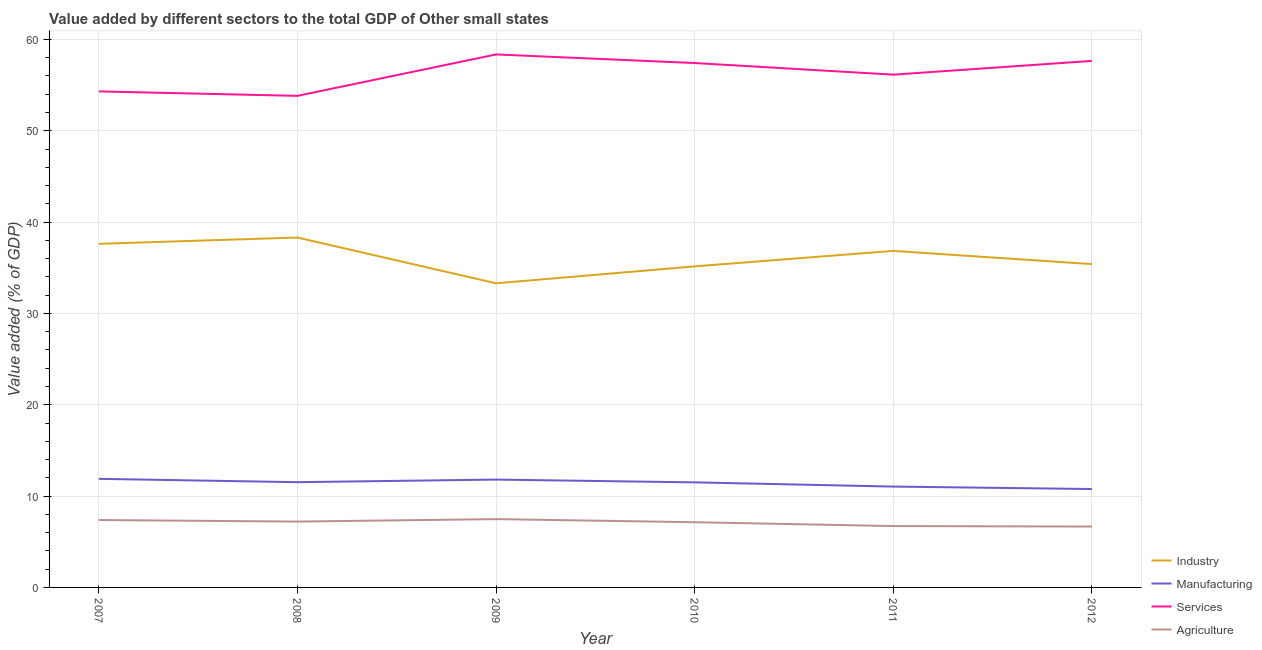Is the number of lines equal to the number of legend labels?
Your response must be concise. Yes. What is the value added by agricultural sector in 2011?
Offer a terse response. 6.72. Across all years, what is the maximum value added by industrial sector?
Your response must be concise. 38.31. Across all years, what is the minimum value added by agricultural sector?
Give a very brief answer. 6.67. In which year was the value added by services sector maximum?
Your response must be concise. 2009. What is the total value added by agricultural sector in the graph?
Make the answer very short. 42.59. What is the difference between the value added by industrial sector in 2009 and that in 2012?
Offer a terse response. -2.1. What is the difference between the value added by agricultural sector in 2009 and the value added by manufacturing sector in 2012?
Offer a terse response. -3.29. What is the average value added by industrial sector per year?
Your response must be concise. 36.1. In the year 2011, what is the difference between the value added by agricultural sector and value added by industrial sector?
Offer a terse response. -30.13. What is the ratio of the value added by agricultural sector in 2007 to that in 2008?
Provide a short and direct response. 1.02. Is the difference between the value added by agricultural sector in 2010 and 2012 greater than the difference between the value added by industrial sector in 2010 and 2012?
Make the answer very short. Yes. What is the difference between the highest and the second highest value added by agricultural sector?
Give a very brief answer. 0.1. What is the difference between the highest and the lowest value added by agricultural sector?
Your response must be concise. 0.81. Does the value added by industrial sector monotonically increase over the years?
Your response must be concise. No. Is the value added by manufacturing sector strictly greater than the value added by services sector over the years?
Offer a very short reply. No. How many years are there in the graph?
Your answer should be compact. 6. What is the difference between two consecutive major ticks on the Y-axis?
Your answer should be very brief. 10. Are the values on the major ticks of Y-axis written in scientific E-notation?
Your answer should be compact. No. Where does the legend appear in the graph?
Your answer should be compact. Bottom right. What is the title of the graph?
Your response must be concise. Value added by different sectors to the total GDP of Other small states. What is the label or title of the Y-axis?
Give a very brief answer. Value added (% of GDP). What is the Value added (% of GDP) of Industry in 2007?
Your answer should be very brief. 37.62. What is the Value added (% of GDP) of Manufacturing in 2007?
Offer a very short reply. 11.89. What is the Value added (% of GDP) in Services in 2007?
Your answer should be compact. 54.31. What is the Value added (% of GDP) of Agriculture in 2007?
Give a very brief answer. 7.38. What is the Value added (% of GDP) in Industry in 2008?
Provide a short and direct response. 38.31. What is the Value added (% of GDP) in Manufacturing in 2008?
Offer a very short reply. 11.52. What is the Value added (% of GDP) of Services in 2008?
Your answer should be compact. 53.82. What is the Value added (% of GDP) of Agriculture in 2008?
Ensure brevity in your answer.  7.21. What is the Value added (% of GDP) of Industry in 2009?
Your answer should be very brief. 33.3. What is the Value added (% of GDP) in Manufacturing in 2009?
Offer a very short reply. 11.81. What is the Value added (% of GDP) of Services in 2009?
Offer a terse response. 58.36. What is the Value added (% of GDP) in Agriculture in 2009?
Make the answer very short. 7.48. What is the Value added (% of GDP) of Industry in 2010?
Ensure brevity in your answer.  35.15. What is the Value added (% of GDP) of Manufacturing in 2010?
Ensure brevity in your answer.  11.5. What is the Value added (% of GDP) of Services in 2010?
Make the answer very short. 57.41. What is the Value added (% of GDP) in Agriculture in 2010?
Offer a very short reply. 7.14. What is the Value added (% of GDP) of Industry in 2011?
Provide a succinct answer. 36.85. What is the Value added (% of GDP) of Manufacturing in 2011?
Your response must be concise. 11.04. What is the Value added (% of GDP) in Services in 2011?
Offer a terse response. 56.14. What is the Value added (% of GDP) in Agriculture in 2011?
Offer a very short reply. 6.72. What is the Value added (% of GDP) in Industry in 2012?
Provide a succinct answer. 35.4. What is the Value added (% of GDP) of Manufacturing in 2012?
Make the answer very short. 10.77. What is the Value added (% of GDP) of Services in 2012?
Offer a very short reply. 57.65. What is the Value added (% of GDP) in Agriculture in 2012?
Provide a succinct answer. 6.67. Across all years, what is the maximum Value added (% of GDP) in Industry?
Keep it short and to the point. 38.31. Across all years, what is the maximum Value added (% of GDP) in Manufacturing?
Offer a terse response. 11.89. Across all years, what is the maximum Value added (% of GDP) in Services?
Make the answer very short. 58.36. Across all years, what is the maximum Value added (% of GDP) in Agriculture?
Provide a succinct answer. 7.48. Across all years, what is the minimum Value added (% of GDP) of Industry?
Provide a succinct answer. 33.3. Across all years, what is the minimum Value added (% of GDP) of Manufacturing?
Your answer should be very brief. 10.77. Across all years, what is the minimum Value added (% of GDP) of Services?
Make the answer very short. 53.82. Across all years, what is the minimum Value added (% of GDP) in Agriculture?
Make the answer very short. 6.67. What is the total Value added (% of GDP) in Industry in the graph?
Your answer should be very brief. 216.62. What is the total Value added (% of GDP) in Manufacturing in the graph?
Keep it short and to the point. 68.54. What is the total Value added (% of GDP) of Services in the graph?
Your answer should be very brief. 337.69. What is the total Value added (% of GDP) of Agriculture in the graph?
Give a very brief answer. 42.59. What is the difference between the Value added (% of GDP) in Industry in 2007 and that in 2008?
Ensure brevity in your answer.  -0.69. What is the difference between the Value added (% of GDP) in Manufacturing in 2007 and that in 2008?
Ensure brevity in your answer.  0.36. What is the difference between the Value added (% of GDP) in Services in 2007 and that in 2008?
Your answer should be very brief. 0.49. What is the difference between the Value added (% of GDP) of Agriculture in 2007 and that in 2008?
Give a very brief answer. 0.17. What is the difference between the Value added (% of GDP) in Industry in 2007 and that in 2009?
Ensure brevity in your answer.  4.32. What is the difference between the Value added (% of GDP) of Manufacturing in 2007 and that in 2009?
Keep it short and to the point. 0.08. What is the difference between the Value added (% of GDP) of Services in 2007 and that in 2009?
Offer a very short reply. -4.05. What is the difference between the Value added (% of GDP) in Agriculture in 2007 and that in 2009?
Provide a short and direct response. -0.1. What is the difference between the Value added (% of GDP) in Industry in 2007 and that in 2010?
Make the answer very short. 2.47. What is the difference between the Value added (% of GDP) in Manufacturing in 2007 and that in 2010?
Your response must be concise. 0.39. What is the difference between the Value added (% of GDP) of Services in 2007 and that in 2010?
Offer a terse response. -3.1. What is the difference between the Value added (% of GDP) of Agriculture in 2007 and that in 2010?
Your answer should be compact. 0.24. What is the difference between the Value added (% of GDP) of Industry in 2007 and that in 2011?
Offer a terse response. 0.77. What is the difference between the Value added (% of GDP) of Manufacturing in 2007 and that in 2011?
Your answer should be very brief. 0.85. What is the difference between the Value added (% of GDP) of Services in 2007 and that in 2011?
Your response must be concise. -1.83. What is the difference between the Value added (% of GDP) in Agriculture in 2007 and that in 2011?
Your answer should be compact. 0.66. What is the difference between the Value added (% of GDP) in Industry in 2007 and that in 2012?
Your answer should be very brief. 2.22. What is the difference between the Value added (% of GDP) of Manufacturing in 2007 and that in 2012?
Make the answer very short. 1.12. What is the difference between the Value added (% of GDP) of Services in 2007 and that in 2012?
Ensure brevity in your answer.  -3.34. What is the difference between the Value added (% of GDP) in Agriculture in 2007 and that in 2012?
Your answer should be very brief. 0.71. What is the difference between the Value added (% of GDP) of Industry in 2008 and that in 2009?
Ensure brevity in your answer.  5.01. What is the difference between the Value added (% of GDP) in Manufacturing in 2008 and that in 2009?
Offer a terse response. -0.28. What is the difference between the Value added (% of GDP) of Services in 2008 and that in 2009?
Provide a succinct answer. -4.54. What is the difference between the Value added (% of GDP) of Agriculture in 2008 and that in 2009?
Make the answer very short. -0.27. What is the difference between the Value added (% of GDP) in Industry in 2008 and that in 2010?
Provide a succinct answer. 3.16. What is the difference between the Value added (% of GDP) in Manufacturing in 2008 and that in 2010?
Keep it short and to the point. 0.02. What is the difference between the Value added (% of GDP) in Services in 2008 and that in 2010?
Your answer should be very brief. -3.59. What is the difference between the Value added (% of GDP) in Agriculture in 2008 and that in 2010?
Provide a succinct answer. 0.07. What is the difference between the Value added (% of GDP) of Industry in 2008 and that in 2011?
Ensure brevity in your answer.  1.46. What is the difference between the Value added (% of GDP) of Manufacturing in 2008 and that in 2011?
Make the answer very short. 0.48. What is the difference between the Value added (% of GDP) in Services in 2008 and that in 2011?
Ensure brevity in your answer.  -2.32. What is the difference between the Value added (% of GDP) in Agriculture in 2008 and that in 2011?
Offer a terse response. 0.49. What is the difference between the Value added (% of GDP) of Industry in 2008 and that in 2012?
Give a very brief answer. 2.91. What is the difference between the Value added (% of GDP) in Manufacturing in 2008 and that in 2012?
Keep it short and to the point. 0.75. What is the difference between the Value added (% of GDP) in Services in 2008 and that in 2012?
Make the answer very short. -3.83. What is the difference between the Value added (% of GDP) in Agriculture in 2008 and that in 2012?
Ensure brevity in your answer.  0.54. What is the difference between the Value added (% of GDP) in Industry in 2009 and that in 2010?
Provide a succinct answer. -1.85. What is the difference between the Value added (% of GDP) of Manufacturing in 2009 and that in 2010?
Offer a terse response. 0.3. What is the difference between the Value added (% of GDP) of Services in 2009 and that in 2010?
Keep it short and to the point. 0.94. What is the difference between the Value added (% of GDP) in Agriculture in 2009 and that in 2010?
Provide a succinct answer. 0.34. What is the difference between the Value added (% of GDP) in Industry in 2009 and that in 2011?
Keep it short and to the point. -3.55. What is the difference between the Value added (% of GDP) in Manufacturing in 2009 and that in 2011?
Your answer should be very brief. 0.77. What is the difference between the Value added (% of GDP) of Services in 2009 and that in 2011?
Your answer should be very brief. 2.21. What is the difference between the Value added (% of GDP) of Agriculture in 2009 and that in 2011?
Make the answer very short. 0.76. What is the difference between the Value added (% of GDP) in Industry in 2009 and that in 2012?
Provide a succinct answer. -2.1. What is the difference between the Value added (% of GDP) in Manufacturing in 2009 and that in 2012?
Provide a short and direct response. 1.04. What is the difference between the Value added (% of GDP) in Services in 2009 and that in 2012?
Provide a succinct answer. 0.71. What is the difference between the Value added (% of GDP) of Agriculture in 2009 and that in 2012?
Your answer should be compact. 0.81. What is the difference between the Value added (% of GDP) of Industry in 2010 and that in 2011?
Keep it short and to the point. -1.7. What is the difference between the Value added (% of GDP) of Manufacturing in 2010 and that in 2011?
Your answer should be compact. 0.46. What is the difference between the Value added (% of GDP) in Services in 2010 and that in 2011?
Keep it short and to the point. 1.27. What is the difference between the Value added (% of GDP) in Agriculture in 2010 and that in 2011?
Your answer should be compact. 0.42. What is the difference between the Value added (% of GDP) of Industry in 2010 and that in 2012?
Ensure brevity in your answer.  -0.25. What is the difference between the Value added (% of GDP) of Manufacturing in 2010 and that in 2012?
Ensure brevity in your answer.  0.73. What is the difference between the Value added (% of GDP) in Services in 2010 and that in 2012?
Offer a terse response. -0.23. What is the difference between the Value added (% of GDP) in Agriculture in 2010 and that in 2012?
Provide a succinct answer. 0.47. What is the difference between the Value added (% of GDP) of Industry in 2011 and that in 2012?
Your answer should be compact. 1.45. What is the difference between the Value added (% of GDP) in Manufacturing in 2011 and that in 2012?
Offer a terse response. 0.27. What is the difference between the Value added (% of GDP) of Services in 2011 and that in 2012?
Offer a very short reply. -1.51. What is the difference between the Value added (% of GDP) in Agriculture in 2011 and that in 2012?
Offer a very short reply. 0.05. What is the difference between the Value added (% of GDP) in Industry in 2007 and the Value added (% of GDP) in Manufacturing in 2008?
Your answer should be compact. 26.1. What is the difference between the Value added (% of GDP) of Industry in 2007 and the Value added (% of GDP) of Services in 2008?
Offer a terse response. -16.2. What is the difference between the Value added (% of GDP) in Industry in 2007 and the Value added (% of GDP) in Agriculture in 2008?
Provide a short and direct response. 30.41. What is the difference between the Value added (% of GDP) in Manufacturing in 2007 and the Value added (% of GDP) in Services in 2008?
Ensure brevity in your answer.  -41.93. What is the difference between the Value added (% of GDP) of Manufacturing in 2007 and the Value added (% of GDP) of Agriculture in 2008?
Make the answer very short. 4.68. What is the difference between the Value added (% of GDP) of Services in 2007 and the Value added (% of GDP) of Agriculture in 2008?
Offer a very short reply. 47.1. What is the difference between the Value added (% of GDP) of Industry in 2007 and the Value added (% of GDP) of Manufacturing in 2009?
Your answer should be compact. 25.81. What is the difference between the Value added (% of GDP) of Industry in 2007 and the Value added (% of GDP) of Services in 2009?
Your answer should be very brief. -20.73. What is the difference between the Value added (% of GDP) in Industry in 2007 and the Value added (% of GDP) in Agriculture in 2009?
Ensure brevity in your answer.  30.14. What is the difference between the Value added (% of GDP) in Manufacturing in 2007 and the Value added (% of GDP) in Services in 2009?
Offer a terse response. -46.47. What is the difference between the Value added (% of GDP) of Manufacturing in 2007 and the Value added (% of GDP) of Agriculture in 2009?
Give a very brief answer. 4.41. What is the difference between the Value added (% of GDP) in Services in 2007 and the Value added (% of GDP) in Agriculture in 2009?
Your response must be concise. 46.83. What is the difference between the Value added (% of GDP) in Industry in 2007 and the Value added (% of GDP) in Manufacturing in 2010?
Offer a very short reply. 26.12. What is the difference between the Value added (% of GDP) in Industry in 2007 and the Value added (% of GDP) in Services in 2010?
Give a very brief answer. -19.79. What is the difference between the Value added (% of GDP) of Industry in 2007 and the Value added (% of GDP) of Agriculture in 2010?
Offer a very short reply. 30.48. What is the difference between the Value added (% of GDP) in Manufacturing in 2007 and the Value added (% of GDP) in Services in 2010?
Your response must be concise. -45.53. What is the difference between the Value added (% of GDP) of Manufacturing in 2007 and the Value added (% of GDP) of Agriculture in 2010?
Provide a succinct answer. 4.75. What is the difference between the Value added (% of GDP) in Services in 2007 and the Value added (% of GDP) in Agriculture in 2010?
Offer a terse response. 47.17. What is the difference between the Value added (% of GDP) of Industry in 2007 and the Value added (% of GDP) of Manufacturing in 2011?
Ensure brevity in your answer.  26.58. What is the difference between the Value added (% of GDP) in Industry in 2007 and the Value added (% of GDP) in Services in 2011?
Your answer should be compact. -18.52. What is the difference between the Value added (% of GDP) of Industry in 2007 and the Value added (% of GDP) of Agriculture in 2011?
Your response must be concise. 30.9. What is the difference between the Value added (% of GDP) of Manufacturing in 2007 and the Value added (% of GDP) of Services in 2011?
Your answer should be very brief. -44.25. What is the difference between the Value added (% of GDP) of Manufacturing in 2007 and the Value added (% of GDP) of Agriculture in 2011?
Offer a very short reply. 5.17. What is the difference between the Value added (% of GDP) of Services in 2007 and the Value added (% of GDP) of Agriculture in 2011?
Keep it short and to the point. 47.59. What is the difference between the Value added (% of GDP) in Industry in 2007 and the Value added (% of GDP) in Manufacturing in 2012?
Your answer should be very brief. 26.85. What is the difference between the Value added (% of GDP) of Industry in 2007 and the Value added (% of GDP) of Services in 2012?
Offer a very short reply. -20.03. What is the difference between the Value added (% of GDP) in Industry in 2007 and the Value added (% of GDP) in Agriculture in 2012?
Your answer should be very brief. 30.96. What is the difference between the Value added (% of GDP) in Manufacturing in 2007 and the Value added (% of GDP) in Services in 2012?
Provide a short and direct response. -45.76. What is the difference between the Value added (% of GDP) of Manufacturing in 2007 and the Value added (% of GDP) of Agriculture in 2012?
Offer a very short reply. 5.22. What is the difference between the Value added (% of GDP) of Services in 2007 and the Value added (% of GDP) of Agriculture in 2012?
Offer a very short reply. 47.64. What is the difference between the Value added (% of GDP) in Industry in 2008 and the Value added (% of GDP) in Manufacturing in 2009?
Offer a terse response. 26.5. What is the difference between the Value added (% of GDP) of Industry in 2008 and the Value added (% of GDP) of Services in 2009?
Make the answer very short. -20.05. What is the difference between the Value added (% of GDP) of Industry in 2008 and the Value added (% of GDP) of Agriculture in 2009?
Offer a very short reply. 30.83. What is the difference between the Value added (% of GDP) in Manufacturing in 2008 and the Value added (% of GDP) in Services in 2009?
Keep it short and to the point. -46.83. What is the difference between the Value added (% of GDP) in Manufacturing in 2008 and the Value added (% of GDP) in Agriculture in 2009?
Provide a succinct answer. 4.05. What is the difference between the Value added (% of GDP) of Services in 2008 and the Value added (% of GDP) of Agriculture in 2009?
Your answer should be very brief. 46.34. What is the difference between the Value added (% of GDP) of Industry in 2008 and the Value added (% of GDP) of Manufacturing in 2010?
Make the answer very short. 26.81. What is the difference between the Value added (% of GDP) of Industry in 2008 and the Value added (% of GDP) of Services in 2010?
Ensure brevity in your answer.  -19.11. What is the difference between the Value added (% of GDP) of Industry in 2008 and the Value added (% of GDP) of Agriculture in 2010?
Offer a terse response. 31.17. What is the difference between the Value added (% of GDP) of Manufacturing in 2008 and the Value added (% of GDP) of Services in 2010?
Ensure brevity in your answer.  -45.89. What is the difference between the Value added (% of GDP) of Manufacturing in 2008 and the Value added (% of GDP) of Agriculture in 2010?
Your response must be concise. 4.38. What is the difference between the Value added (% of GDP) in Services in 2008 and the Value added (% of GDP) in Agriculture in 2010?
Make the answer very short. 46.68. What is the difference between the Value added (% of GDP) in Industry in 2008 and the Value added (% of GDP) in Manufacturing in 2011?
Provide a short and direct response. 27.27. What is the difference between the Value added (% of GDP) in Industry in 2008 and the Value added (% of GDP) in Services in 2011?
Your answer should be very brief. -17.83. What is the difference between the Value added (% of GDP) of Industry in 2008 and the Value added (% of GDP) of Agriculture in 2011?
Make the answer very short. 31.59. What is the difference between the Value added (% of GDP) in Manufacturing in 2008 and the Value added (% of GDP) in Services in 2011?
Your answer should be compact. -44.62. What is the difference between the Value added (% of GDP) of Manufacturing in 2008 and the Value added (% of GDP) of Agriculture in 2011?
Ensure brevity in your answer.  4.81. What is the difference between the Value added (% of GDP) in Services in 2008 and the Value added (% of GDP) in Agriculture in 2011?
Offer a very short reply. 47.1. What is the difference between the Value added (% of GDP) in Industry in 2008 and the Value added (% of GDP) in Manufacturing in 2012?
Make the answer very short. 27.54. What is the difference between the Value added (% of GDP) in Industry in 2008 and the Value added (% of GDP) in Services in 2012?
Ensure brevity in your answer.  -19.34. What is the difference between the Value added (% of GDP) in Industry in 2008 and the Value added (% of GDP) in Agriculture in 2012?
Your response must be concise. 31.64. What is the difference between the Value added (% of GDP) in Manufacturing in 2008 and the Value added (% of GDP) in Services in 2012?
Offer a very short reply. -46.12. What is the difference between the Value added (% of GDP) in Manufacturing in 2008 and the Value added (% of GDP) in Agriculture in 2012?
Your answer should be compact. 4.86. What is the difference between the Value added (% of GDP) of Services in 2008 and the Value added (% of GDP) of Agriculture in 2012?
Provide a succinct answer. 47.15. What is the difference between the Value added (% of GDP) in Industry in 2009 and the Value added (% of GDP) in Manufacturing in 2010?
Provide a succinct answer. 21.8. What is the difference between the Value added (% of GDP) of Industry in 2009 and the Value added (% of GDP) of Services in 2010?
Your answer should be compact. -24.11. What is the difference between the Value added (% of GDP) of Industry in 2009 and the Value added (% of GDP) of Agriculture in 2010?
Offer a terse response. 26.16. What is the difference between the Value added (% of GDP) of Manufacturing in 2009 and the Value added (% of GDP) of Services in 2010?
Offer a very short reply. -45.61. What is the difference between the Value added (% of GDP) in Manufacturing in 2009 and the Value added (% of GDP) in Agriculture in 2010?
Keep it short and to the point. 4.67. What is the difference between the Value added (% of GDP) in Services in 2009 and the Value added (% of GDP) in Agriculture in 2010?
Offer a very short reply. 51.22. What is the difference between the Value added (% of GDP) in Industry in 2009 and the Value added (% of GDP) in Manufacturing in 2011?
Offer a terse response. 22.26. What is the difference between the Value added (% of GDP) in Industry in 2009 and the Value added (% of GDP) in Services in 2011?
Ensure brevity in your answer.  -22.84. What is the difference between the Value added (% of GDP) of Industry in 2009 and the Value added (% of GDP) of Agriculture in 2011?
Keep it short and to the point. 26.58. What is the difference between the Value added (% of GDP) of Manufacturing in 2009 and the Value added (% of GDP) of Services in 2011?
Give a very brief answer. -44.33. What is the difference between the Value added (% of GDP) of Manufacturing in 2009 and the Value added (% of GDP) of Agriculture in 2011?
Ensure brevity in your answer.  5.09. What is the difference between the Value added (% of GDP) of Services in 2009 and the Value added (% of GDP) of Agriculture in 2011?
Your answer should be compact. 51.64. What is the difference between the Value added (% of GDP) in Industry in 2009 and the Value added (% of GDP) in Manufacturing in 2012?
Give a very brief answer. 22.53. What is the difference between the Value added (% of GDP) in Industry in 2009 and the Value added (% of GDP) in Services in 2012?
Provide a short and direct response. -24.35. What is the difference between the Value added (% of GDP) in Industry in 2009 and the Value added (% of GDP) in Agriculture in 2012?
Keep it short and to the point. 26.63. What is the difference between the Value added (% of GDP) of Manufacturing in 2009 and the Value added (% of GDP) of Services in 2012?
Make the answer very short. -45.84. What is the difference between the Value added (% of GDP) of Manufacturing in 2009 and the Value added (% of GDP) of Agriculture in 2012?
Offer a terse response. 5.14. What is the difference between the Value added (% of GDP) of Services in 2009 and the Value added (% of GDP) of Agriculture in 2012?
Keep it short and to the point. 51.69. What is the difference between the Value added (% of GDP) of Industry in 2010 and the Value added (% of GDP) of Manufacturing in 2011?
Keep it short and to the point. 24.11. What is the difference between the Value added (% of GDP) of Industry in 2010 and the Value added (% of GDP) of Services in 2011?
Your answer should be very brief. -20.99. What is the difference between the Value added (% of GDP) of Industry in 2010 and the Value added (% of GDP) of Agriculture in 2011?
Your answer should be compact. 28.43. What is the difference between the Value added (% of GDP) of Manufacturing in 2010 and the Value added (% of GDP) of Services in 2011?
Keep it short and to the point. -44.64. What is the difference between the Value added (% of GDP) in Manufacturing in 2010 and the Value added (% of GDP) in Agriculture in 2011?
Ensure brevity in your answer.  4.78. What is the difference between the Value added (% of GDP) of Services in 2010 and the Value added (% of GDP) of Agriculture in 2011?
Your answer should be very brief. 50.69. What is the difference between the Value added (% of GDP) of Industry in 2010 and the Value added (% of GDP) of Manufacturing in 2012?
Provide a short and direct response. 24.38. What is the difference between the Value added (% of GDP) of Industry in 2010 and the Value added (% of GDP) of Services in 2012?
Provide a short and direct response. -22.5. What is the difference between the Value added (% of GDP) of Industry in 2010 and the Value added (% of GDP) of Agriculture in 2012?
Provide a succinct answer. 28.48. What is the difference between the Value added (% of GDP) in Manufacturing in 2010 and the Value added (% of GDP) in Services in 2012?
Your answer should be very brief. -46.15. What is the difference between the Value added (% of GDP) of Manufacturing in 2010 and the Value added (% of GDP) of Agriculture in 2012?
Make the answer very short. 4.84. What is the difference between the Value added (% of GDP) in Services in 2010 and the Value added (% of GDP) in Agriculture in 2012?
Offer a very short reply. 50.75. What is the difference between the Value added (% of GDP) in Industry in 2011 and the Value added (% of GDP) in Manufacturing in 2012?
Your response must be concise. 26.07. What is the difference between the Value added (% of GDP) of Industry in 2011 and the Value added (% of GDP) of Services in 2012?
Give a very brief answer. -20.8. What is the difference between the Value added (% of GDP) in Industry in 2011 and the Value added (% of GDP) in Agriculture in 2012?
Offer a terse response. 30.18. What is the difference between the Value added (% of GDP) in Manufacturing in 2011 and the Value added (% of GDP) in Services in 2012?
Keep it short and to the point. -46.61. What is the difference between the Value added (% of GDP) of Manufacturing in 2011 and the Value added (% of GDP) of Agriculture in 2012?
Keep it short and to the point. 4.38. What is the difference between the Value added (% of GDP) of Services in 2011 and the Value added (% of GDP) of Agriculture in 2012?
Your response must be concise. 49.48. What is the average Value added (% of GDP) in Industry per year?
Give a very brief answer. 36.1. What is the average Value added (% of GDP) of Manufacturing per year?
Offer a very short reply. 11.42. What is the average Value added (% of GDP) in Services per year?
Ensure brevity in your answer.  56.28. What is the average Value added (% of GDP) in Agriculture per year?
Your answer should be very brief. 7.1. In the year 2007, what is the difference between the Value added (% of GDP) of Industry and Value added (% of GDP) of Manufacturing?
Your response must be concise. 25.73. In the year 2007, what is the difference between the Value added (% of GDP) of Industry and Value added (% of GDP) of Services?
Provide a succinct answer. -16.69. In the year 2007, what is the difference between the Value added (% of GDP) of Industry and Value added (% of GDP) of Agriculture?
Provide a succinct answer. 30.24. In the year 2007, what is the difference between the Value added (% of GDP) in Manufacturing and Value added (% of GDP) in Services?
Provide a succinct answer. -42.42. In the year 2007, what is the difference between the Value added (% of GDP) of Manufacturing and Value added (% of GDP) of Agriculture?
Ensure brevity in your answer.  4.51. In the year 2007, what is the difference between the Value added (% of GDP) of Services and Value added (% of GDP) of Agriculture?
Your response must be concise. 46.93. In the year 2008, what is the difference between the Value added (% of GDP) in Industry and Value added (% of GDP) in Manufacturing?
Keep it short and to the point. 26.78. In the year 2008, what is the difference between the Value added (% of GDP) in Industry and Value added (% of GDP) in Services?
Your response must be concise. -15.51. In the year 2008, what is the difference between the Value added (% of GDP) in Industry and Value added (% of GDP) in Agriculture?
Your answer should be compact. 31.1. In the year 2008, what is the difference between the Value added (% of GDP) of Manufacturing and Value added (% of GDP) of Services?
Keep it short and to the point. -42.3. In the year 2008, what is the difference between the Value added (% of GDP) of Manufacturing and Value added (% of GDP) of Agriculture?
Your answer should be compact. 4.31. In the year 2008, what is the difference between the Value added (% of GDP) in Services and Value added (% of GDP) in Agriculture?
Make the answer very short. 46.61. In the year 2009, what is the difference between the Value added (% of GDP) of Industry and Value added (% of GDP) of Manufacturing?
Your response must be concise. 21.49. In the year 2009, what is the difference between the Value added (% of GDP) in Industry and Value added (% of GDP) in Services?
Make the answer very short. -25.06. In the year 2009, what is the difference between the Value added (% of GDP) of Industry and Value added (% of GDP) of Agriculture?
Ensure brevity in your answer.  25.82. In the year 2009, what is the difference between the Value added (% of GDP) of Manufacturing and Value added (% of GDP) of Services?
Provide a succinct answer. -46.55. In the year 2009, what is the difference between the Value added (% of GDP) in Manufacturing and Value added (% of GDP) in Agriculture?
Ensure brevity in your answer.  4.33. In the year 2009, what is the difference between the Value added (% of GDP) of Services and Value added (% of GDP) of Agriculture?
Keep it short and to the point. 50.88. In the year 2010, what is the difference between the Value added (% of GDP) in Industry and Value added (% of GDP) in Manufacturing?
Provide a succinct answer. 23.65. In the year 2010, what is the difference between the Value added (% of GDP) in Industry and Value added (% of GDP) in Services?
Your response must be concise. -22.26. In the year 2010, what is the difference between the Value added (% of GDP) of Industry and Value added (% of GDP) of Agriculture?
Provide a succinct answer. 28.01. In the year 2010, what is the difference between the Value added (% of GDP) of Manufacturing and Value added (% of GDP) of Services?
Ensure brevity in your answer.  -45.91. In the year 2010, what is the difference between the Value added (% of GDP) in Manufacturing and Value added (% of GDP) in Agriculture?
Offer a very short reply. 4.36. In the year 2010, what is the difference between the Value added (% of GDP) of Services and Value added (% of GDP) of Agriculture?
Offer a very short reply. 50.27. In the year 2011, what is the difference between the Value added (% of GDP) of Industry and Value added (% of GDP) of Manufacturing?
Ensure brevity in your answer.  25.81. In the year 2011, what is the difference between the Value added (% of GDP) in Industry and Value added (% of GDP) in Services?
Your response must be concise. -19.29. In the year 2011, what is the difference between the Value added (% of GDP) in Industry and Value added (% of GDP) in Agriculture?
Offer a terse response. 30.13. In the year 2011, what is the difference between the Value added (% of GDP) in Manufacturing and Value added (% of GDP) in Services?
Keep it short and to the point. -45.1. In the year 2011, what is the difference between the Value added (% of GDP) of Manufacturing and Value added (% of GDP) of Agriculture?
Offer a very short reply. 4.32. In the year 2011, what is the difference between the Value added (% of GDP) of Services and Value added (% of GDP) of Agriculture?
Your response must be concise. 49.42. In the year 2012, what is the difference between the Value added (% of GDP) in Industry and Value added (% of GDP) in Manufacturing?
Provide a short and direct response. 24.63. In the year 2012, what is the difference between the Value added (% of GDP) in Industry and Value added (% of GDP) in Services?
Keep it short and to the point. -22.25. In the year 2012, what is the difference between the Value added (% of GDP) of Industry and Value added (% of GDP) of Agriculture?
Provide a short and direct response. 28.73. In the year 2012, what is the difference between the Value added (% of GDP) of Manufacturing and Value added (% of GDP) of Services?
Your answer should be very brief. -46.88. In the year 2012, what is the difference between the Value added (% of GDP) of Manufacturing and Value added (% of GDP) of Agriculture?
Ensure brevity in your answer.  4.11. In the year 2012, what is the difference between the Value added (% of GDP) in Services and Value added (% of GDP) in Agriculture?
Make the answer very short. 50.98. What is the ratio of the Value added (% of GDP) of Industry in 2007 to that in 2008?
Ensure brevity in your answer.  0.98. What is the ratio of the Value added (% of GDP) of Manufacturing in 2007 to that in 2008?
Offer a terse response. 1.03. What is the ratio of the Value added (% of GDP) of Services in 2007 to that in 2008?
Give a very brief answer. 1.01. What is the ratio of the Value added (% of GDP) in Agriculture in 2007 to that in 2008?
Your answer should be very brief. 1.02. What is the ratio of the Value added (% of GDP) of Industry in 2007 to that in 2009?
Provide a succinct answer. 1.13. What is the ratio of the Value added (% of GDP) of Services in 2007 to that in 2009?
Provide a succinct answer. 0.93. What is the ratio of the Value added (% of GDP) in Agriculture in 2007 to that in 2009?
Ensure brevity in your answer.  0.99. What is the ratio of the Value added (% of GDP) of Industry in 2007 to that in 2010?
Your answer should be very brief. 1.07. What is the ratio of the Value added (% of GDP) of Manufacturing in 2007 to that in 2010?
Provide a short and direct response. 1.03. What is the ratio of the Value added (% of GDP) in Services in 2007 to that in 2010?
Your answer should be very brief. 0.95. What is the ratio of the Value added (% of GDP) of Agriculture in 2007 to that in 2010?
Offer a terse response. 1.03. What is the ratio of the Value added (% of GDP) in Manufacturing in 2007 to that in 2011?
Provide a short and direct response. 1.08. What is the ratio of the Value added (% of GDP) of Services in 2007 to that in 2011?
Give a very brief answer. 0.97. What is the ratio of the Value added (% of GDP) of Agriculture in 2007 to that in 2011?
Your response must be concise. 1.1. What is the ratio of the Value added (% of GDP) in Industry in 2007 to that in 2012?
Offer a very short reply. 1.06. What is the ratio of the Value added (% of GDP) of Manufacturing in 2007 to that in 2012?
Make the answer very short. 1.1. What is the ratio of the Value added (% of GDP) of Services in 2007 to that in 2012?
Provide a short and direct response. 0.94. What is the ratio of the Value added (% of GDP) in Agriculture in 2007 to that in 2012?
Your answer should be very brief. 1.11. What is the ratio of the Value added (% of GDP) in Industry in 2008 to that in 2009?
Make the answer very short. 1.15. What is the ratio of the Value added (% of GDP) of Manufacturing in 2008 to that in 2009?
Offer a terse response. 0.98. What is the ratio of the Value added (% of GDP) of Services in 2008 to that in 2009?
Your response must be concise. 0.92. What is the ratio of the Value added (% of GDP) of Agriculture in 2008 to that in 2009?
Offer a terse response. 0.96. What is the ratio of the Value added (% of GDP) of Industry in 2008 to that in 2010?
Ensure brevity in your answer.  1.09. What is the ratio of the Value added (% of GDP) of Manufacturing in 2008 to that in 2010?
Give a very brief answer. 1. What is the ratio of the Value added (% of GDP) of Services in 2008 to that in 2010?
Your answer should be compact. 0.94. What is the ratio of the Value added (% of GDP) in Agriculture in 2008 to that in 2010?
Make the answer very short. 1.01. What is the ratio of the Value added (% of GDP) in Industry in 2008 to that in 2011?
Offer a very short reply. 1.04. What is the ratio of the Value added (% of GDP) of Manufacturing in 2008 to that in 2011?
Provide a short and direct response. 1.04. What is the ratio of the Value added (% of GDP) in Services in 2008 to that in 2011?
Provide a short and direct response. 0.96. What is the ratio of the Value added (% of GDP) in Agriculture in 2008 to that in 2011?
Provide a short and direct response. 1.07. What is the ratio of the Value added (% of GDP) of Industry in 2008 to that in 2012?
Offer a terse response. 1.08. What is the ratio of the Value added (% of GDP) of Manufacturing in 2008 to that in 2012?
Give a very brief answer. 1.07. What is the ratio of the Value added (% of GDP) in Services in 2008 to that in 2012?
Provide a succinct answer. 0.93. What is the ratio of the Value added (% of GDP) of Agriculture in 2008 to that in 2012?
Your answer should be compact. 1.08. What is the ratio of the Value added (% of GDP) of Industry in 2009 to that in 2010?
Offer a terse response. 0.95. What is the ratio of the Value added (% of GDP) in Manufacturing in 2009 to that in 2010?
Ensure brevity in your answer.  1.03. What is the ratio of the Value added (% of GDP) in Services in 2009 to that in 2010?
Offer a terse response. 1.02. What is the ratio of the Value added (% of GDP) of Agriculture in 2009 to that in 2010?
Ensure brevity in your answer.  1.05. What is the ratio of the Value added (% of GDP) of Industry in 2009 to that in 2011?
Give a very brief answer. 0.9. What is the ratio of the Value added (% of GDP) of Manufacturing in 2009 to that in 2011?
Make the answer very short. 1.07. What is the ratio of the Value added (% of GDP) of Services in 2009 to that in 2011?
Offer a terse response. 1.04. What is the ratio of the Value added (% of GDP) of Agriculture in 2009 to that in 2011?
Ensure brevity in your answer.  1.11. What is the ratio of the Value added (% of GDP) in Industry in 2009 to that in 2012?
Provide a succinct answer. 0.94. What is the ratio of the Value added (% of GDP) of Manufacturing in 2009 to that in 2012?
Give a very brief answer. 1.1. What is the ratio of the Value added (% of GDP) in Services in 2009 to that in 2012?
Your answer should be compact. 1.01. What is the ratio of the Value added (% of GDP) of Agriculture in 2009 to that in 2012?
Your response must be concise. 1.12. What is the ratio of the Value added (% of GDP) in Industry in 2010 to that in 2011?
Your response must be concise. 0.95. What is the ratio of the Value added (% of GDP) of Manufacturing in 2010 to that in 2011?
Your answer should be compact. 1.04. What is the ratio of the Value added (% of GDP) of Services in 2010 to that in 2011?
Ensure brevity in your answer.  1.02. What is the ratio of the Value added (% of GDP) in Agriculture in 2010 to that in 2011?
Your answer should be compact. 1.06. What is the ratio of the Value added (% of GDP) in Manufacturing in 2010 to that in 2012?
Your answer should be compact. 1.07. What is the ratio of the Value added (% of GDP) of Agriculture in 2010 to that in 2012?
Offer a terse response. 1.07. What is the ratio of the Value added (% of GDP) in Industry in 2011 to that in 2012?
Your answer should be compact. 1.04. What is the ratio of the Value added (% of GDP) of Manufacturing in 2011 to that in 2012?
Offer a terse response. 1.02. What is the ratio of the Value added (% of GDP) of Services in 2011 to that in 2012?
Ensure brevity in your answer.  0.97. What is the difference between the highest and the second highest Value added (% of GDP) in Industry?
Make the answer very short. 0.69. What is the difference between the highest and the second highest Value added (% of GDP) of Manufacturing?
Your response must be concise. 0.08. What is the difference between the highest and the second highest Value added (% of GDP) of Services?
Provide a succinct answer. 0.71. What is the difference between the highest and the second highest Value added (% of GDP) of Agriculture?
Your response must be concise. 0.1. What is the difference between the highest and the lowest Value added (% of GDP) of Industry?
Provide a short and direct response. 5.01. What is the difference between the highest and the lowest Value added (% of GDP) in Manufacturing?
Your response must be concise. 1.12. What is the difference between the highest and the lowest Value added (% of GDP) in Services?
Keep it short and to the point. 4.54. What is the difference between the highest and the lowest Value added (% of GDP) in Agriculture?
Your response must be concise. 0.81. 